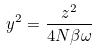<formula> <loc_0><loc_0><loc_500><loc_500>y ^ { 2 } = \frac { z ^ { 2 } } { 4 N \beta \omega }</formula> 